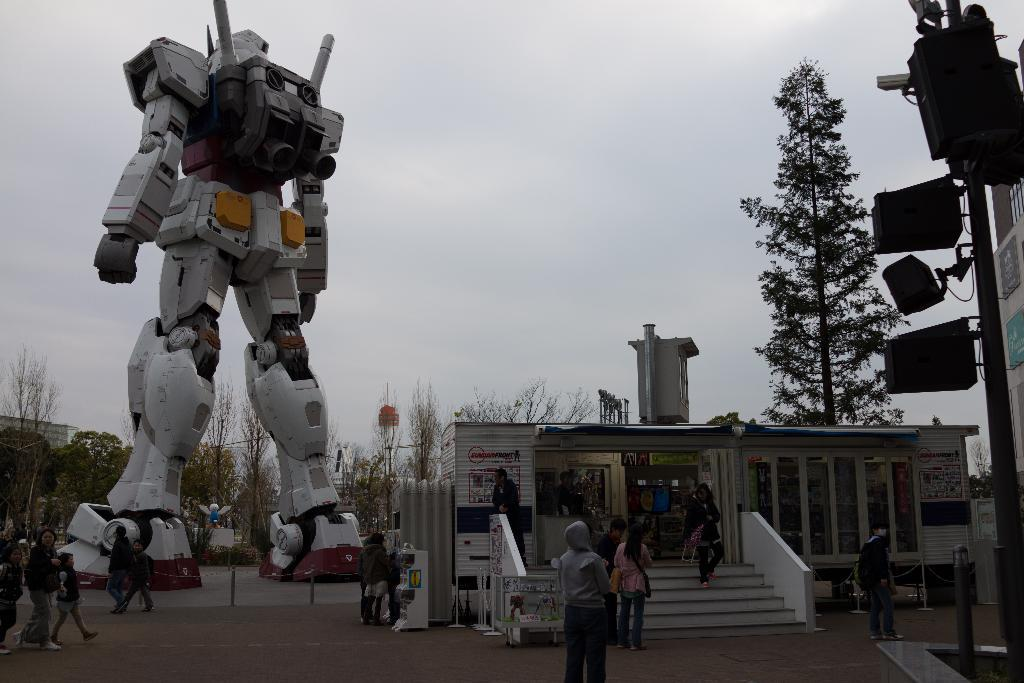How many people are in the image? There are people in the image, but the exact number is not specified. What is on the road in the image? There is a robot on the road in the image. What objects can be seen in the image besides the people and the robot? There are poles, devices, a store, steps, boards, trees, and a wall visible in the image. What can be seen in the background of the image? There is a wall and sky visible in the background of the image. What type of pest can be seen climbing on the tree in the image? There is no tree present in the image, so there is no pest climbing on it. How many men are visible in the image? The facts do not specify the number of men or the gender of the people in the image, so we cannot determine the number of men. 